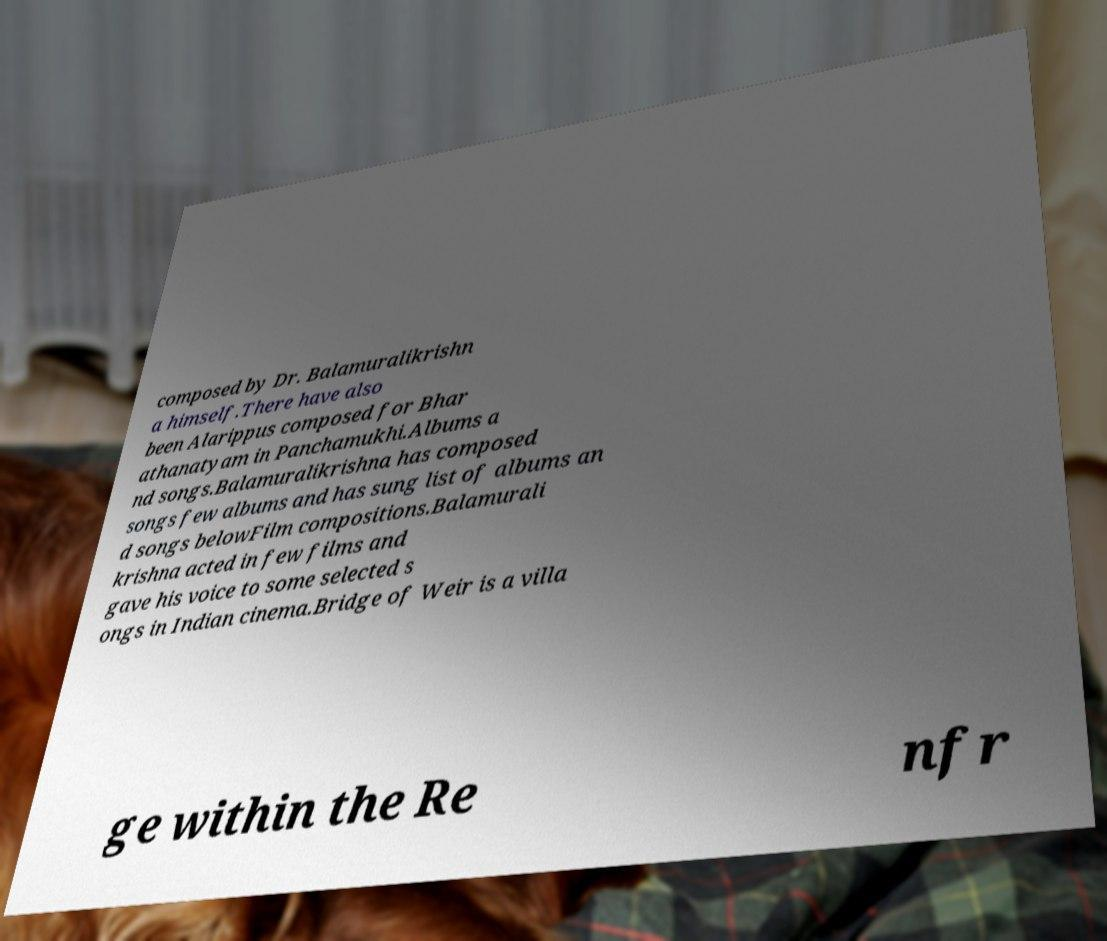I need the written content from this picture converted into text. Can you do that? composed by Dr. Balamuralikrishn a himself.There have also been Alarippus composed for Bhar athanatyam in Panchamukhi.Albums a nd songs.Balamuralikrishna has composed songs few albums and has sung list of albums an d songs belowFilm compositions.Balamurali krishna acted in few films and gave his voice to some selected s ongs in Indian cinema.Bridge of Weir is a villa ge within the Re nfr 